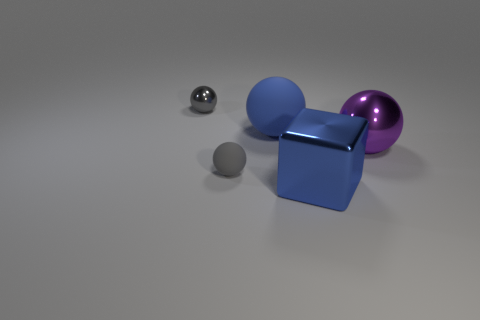Subtract all blue balls. How many balls are left? 3 Subtract all purple balls. Subtract all red cubes. How many balls are left? 3 Add 2 gray metal balls. How many objects exist? 7 Subtract all blocks. How many objects are left? 4 Subtract 0 blue cylinders. How many objects are left? 5 Subtract all tiny purple rubber blocks. Subtract all gray spheres. How many objects are left? 3 Add 5 large blue rubber things. How many large blue rubber things are left? 6 Add 2 blue matte spheres. How many blue matte spheres exist? 3 